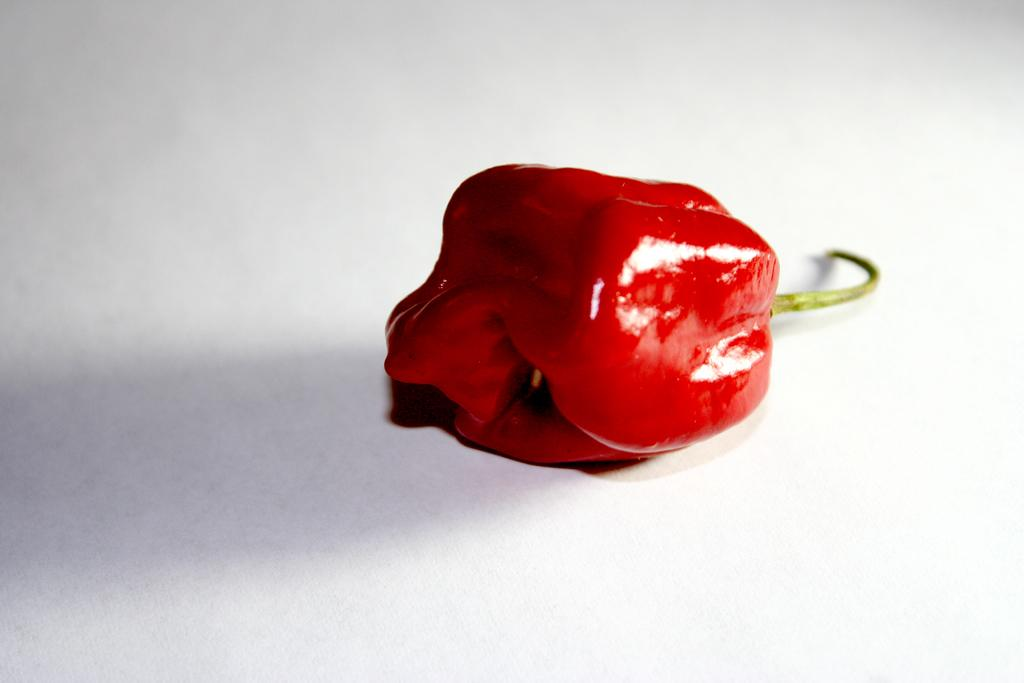What type of vegetable is present in the image? There are red capsicums in the image. What is the color of the surface on which the capsicums are placed? The capsicums are on a white surface. What type of sand can be seen in the image? There is no sand present in the image; it features red capsicums on a white surface. What kind of lead is visible in the image? There is no lead present in the image; it features red capsicums on a white surface. 